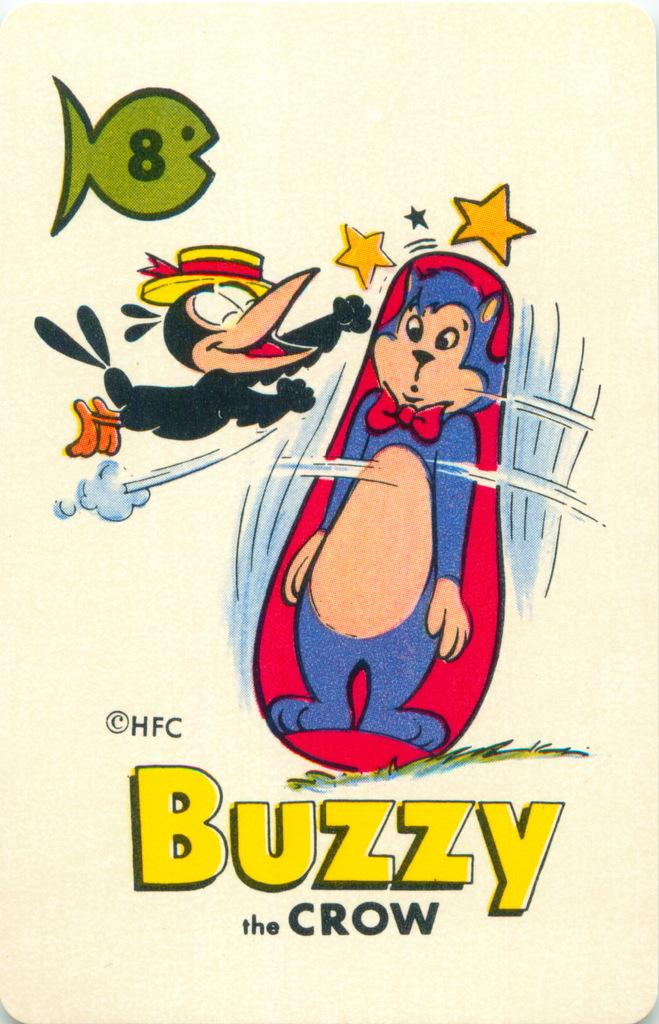What type of images can be seen in the picture? There are cartoons in the image. Are there any words or letters visible in the image? Yes, there is text visible in the image. How does the cartoon maintain a quiet environment in the image? The cartoon does not actively maintain a quiet environment in the image; it is a static image. 